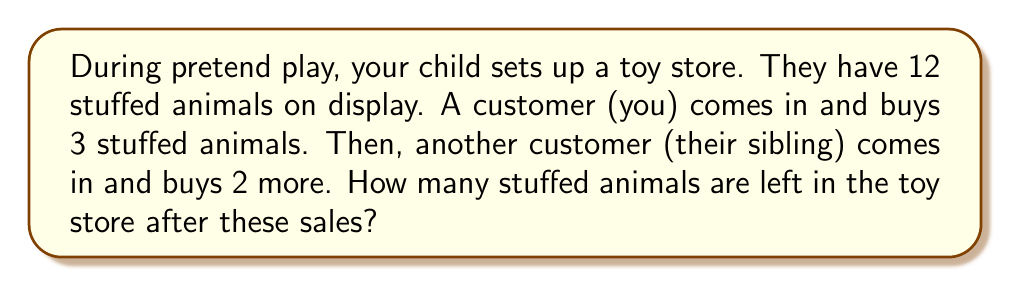Give your solution to this math problem. Let's break this down step-by-step:

1. Initial number of stuffed animals:
   $$ \text{Initial count} = 12 $$

2. First sale (to you):
   $$ \text{First sale} = 3 $$

3. Remaining after first sale:
   $$ 12 - 3 = 9 $$

4. Second sale (to sibling):
   $$ \text{Second sale} = 2 $$

5. Final count after both sales:
   $$ 9 - 2 = 7 $$

This problem involves two subtraction operations:
$$ 12 - 3 - 2 = 7 $$

We can also think of this as one combined subtraction:
$$ 12 - (3 + 2) = 12 - 5 = 7 $$

Both approaches lead to the same result, reinforcing the concept of subtraction within a storytelling context.
Answer: 7 stuffed animals 